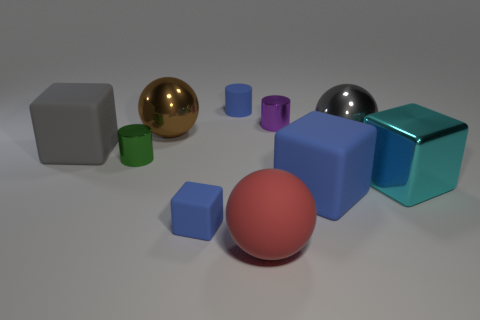There is a shiny ball right of the large rubber block in front of the big matte object to the left of the small green object; how big is it?
Offer a terse response. Large. Is the material of the large sphere that is in front of the gray ball the same as the tiny blue cylinder?
Offer a terse response. Yes. Is the number of purple shiny objects that are left of the big brown metal thing the same as the number of rubber things behind the small purple object?
Give a very brief answer. No. Is there any other thing that is the same size as the cyan metal block?
Your response must be concise. Yes. What material is the large blue object that is the same shape as the large gray rubber thing?
Make the answer very short. Rubber. There is a large matte block to the left of the blue cylinder behind the large matte sphere; are there any big shiny things that are behind it?
Give a very brief answer. Yes. Is the shape of the tiny blue matte thing in front of the cyan cube the same as the big gray object that is left of the small purple object?
Your answer should be compact. Yes. Is the number of big cubes to the left of the gray cube greater than the number of cyan metal things?
Give a very brief answer. No. What number of objects are either tiny cylinders or tiny cubes?
Provide a succinct answer. 4. The matte cylinder has what color?
Ensure brevity in your answer.  Blue. 